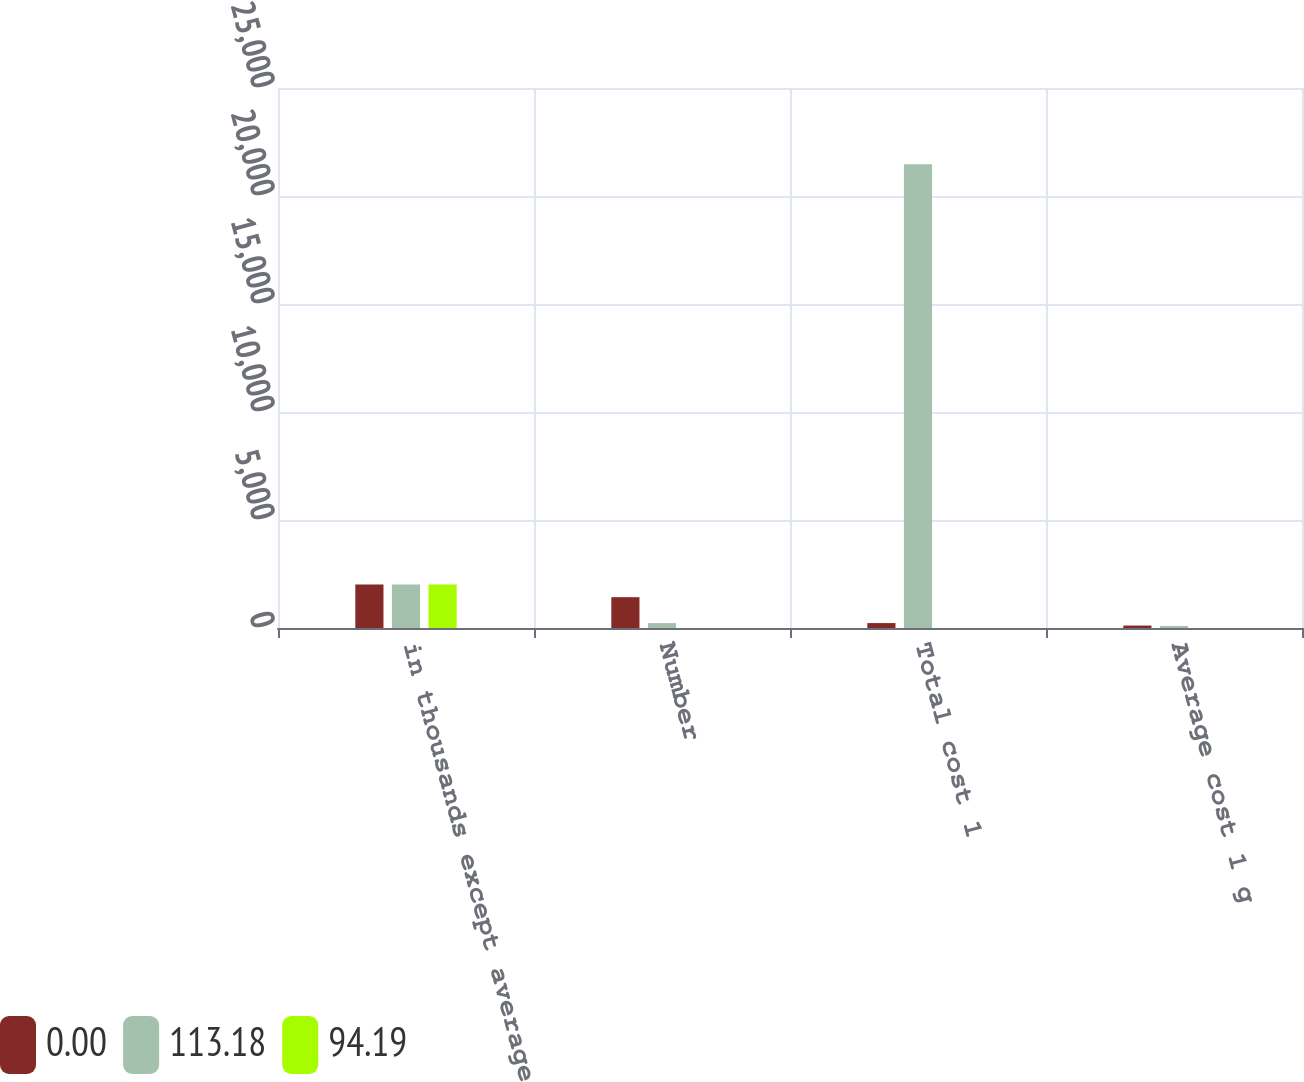Convert chart to OTSL. <chart><loc_0><loc_0><loc_500><loc_500><stacked_bar_chart><ecel><fcel>in thousands except average<fcel>Number<fcel>Total cost 1<fcel>Average cost 1 g<nl><fcel>0<fcel>2016<fcel>1427<fcel>228<fcel>113.18<nl><fcel>113.18<fcel>2015<fcel>228<fcel>21475<fcel>94.19<nl><fcel>94.19<fcel>2014<fcel>0<fcel>0<fcel>0<nl></chart> 